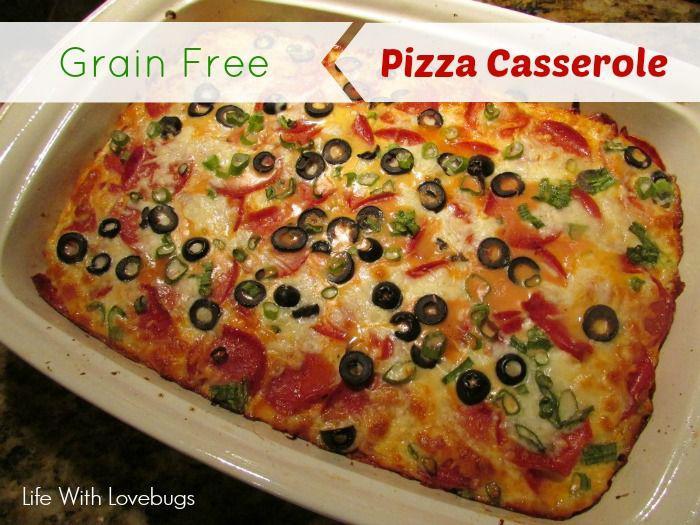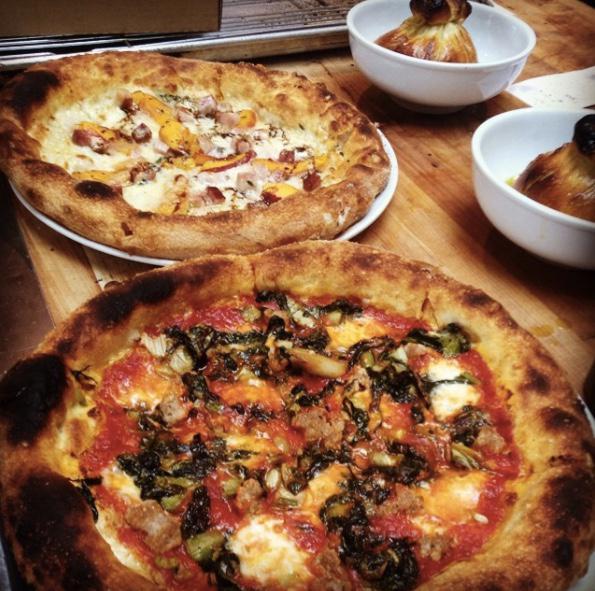The first image is the image on the left, the second image is the image on the right. Examine the images to the left and right. Is the description "All of the pizzas are cooked, whole pizzas." accurate? Answer yes or no. Yes. The first image is the image on the left, the second image is the image on the right. Examine the images to the left and right. Is the description "There are more pizzas in the image on the right." accurate? Answer yes or no. Yes. 